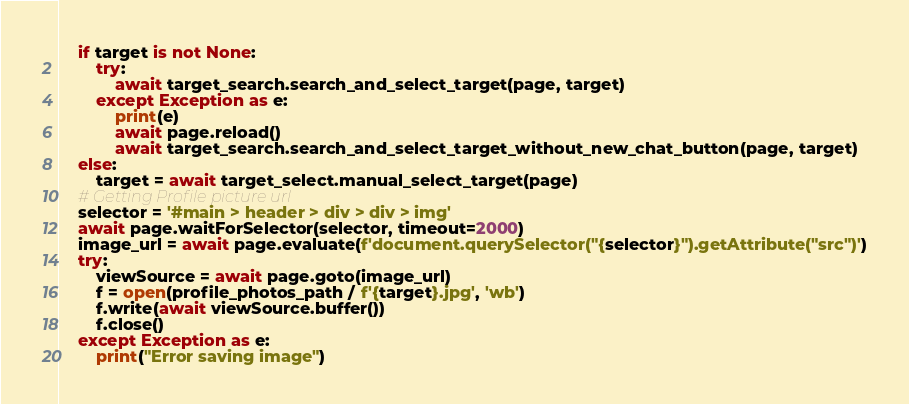<code> <loc_0><loc_0><loc_500><loc_500><_Python_>    if target is not None:
        try:
            await target_search.search_and_select_target(page, target)
        except Exception as e:
            print(e)
            await page.reload()
            await target_search.search_and_select_target_without_new_chat_button(page, target)
    else:
        target = await target_select.manual_select_target(page)
    # Getting Profile picture url
    selector = '#main > header > div > div > img'
    await page.waitForSelector(selector, timeout=2000)
    image_url = await page.evaluate(f'document.querySelector("{selector}").getAttribute("src")')
    try:
        viewSource = await page.goto(image_url)
        f = open(profile_photos_path / f'{target}.jpg', 'wb')
        f.write(await viewSource.buffer())
        f.close()
    except Exception as e:
        print("Error saving image")
</code> 